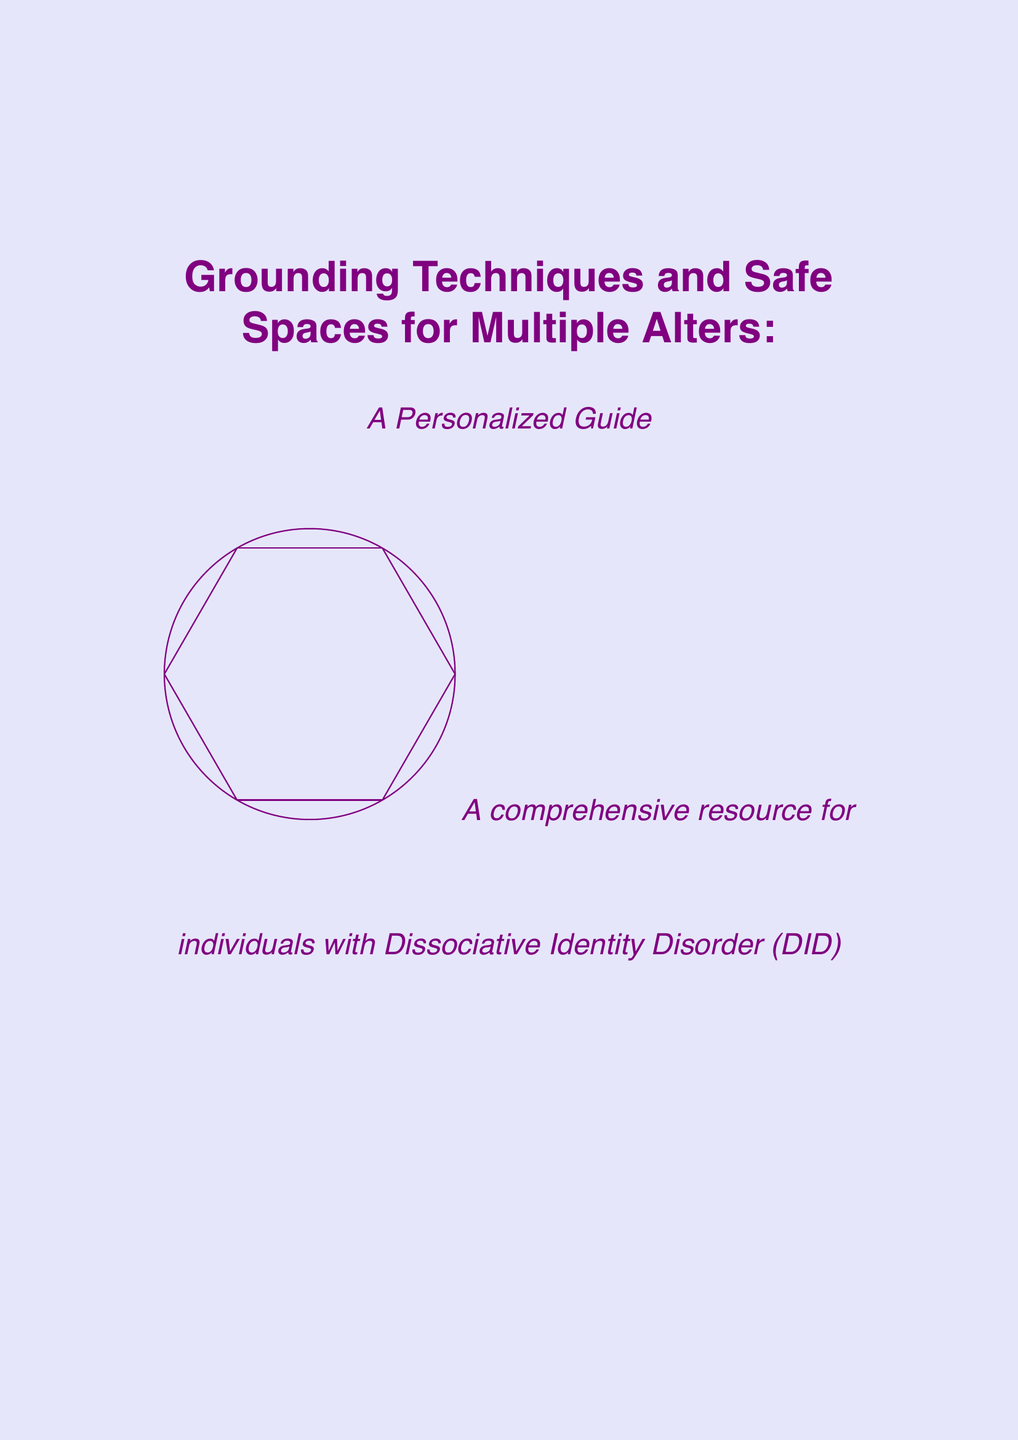What is the title of the manual? The title is provided clearly in the document as the main heading.
Answer: Grounding Techniques and Safe Spaces for Multiple Alters: A Personalized Guide What is the purpose of this guide? The purpose is explained in the introduction section of the document.
Answer: To provide a comprehensive resource for individuals with Dissociative Identity Disorder (DID) to manage their alters and promote integration How many grounding techniques are listed in the document? The total number of grounding techniques can be counted from the respective section.
Answer: 3 What is one element of the Inner Sanctuary Visualization? The document lists various elements under the Inner Sanctuary Visualization section.
Answer: Peaceful natural setting Who is the protector alter mentioned in the guide? The document specifies the name of the protector alter in the personalized coping mechanisms section.
Answer: Sarah What method uses controlled breathing for calming the nervous system? The method is identified by its specific name in the grounding techniques section of the document.
Answer: Rhythmic Breathing What is one resource type listed in the document? This is asking for the type of resources mentioned at the end of the document.
Answer: Books What is the first step in Progressive Muscle Relaxation? The steps are listed in order, and this is the first one from the self-soothing methods section.
Answer: Start with feet and toes How are entries written in Shared Journaling differentiated? The document mentions a guideline for communication between alters through journaling.
Answer: Use different colors or styles to differentiate alters 